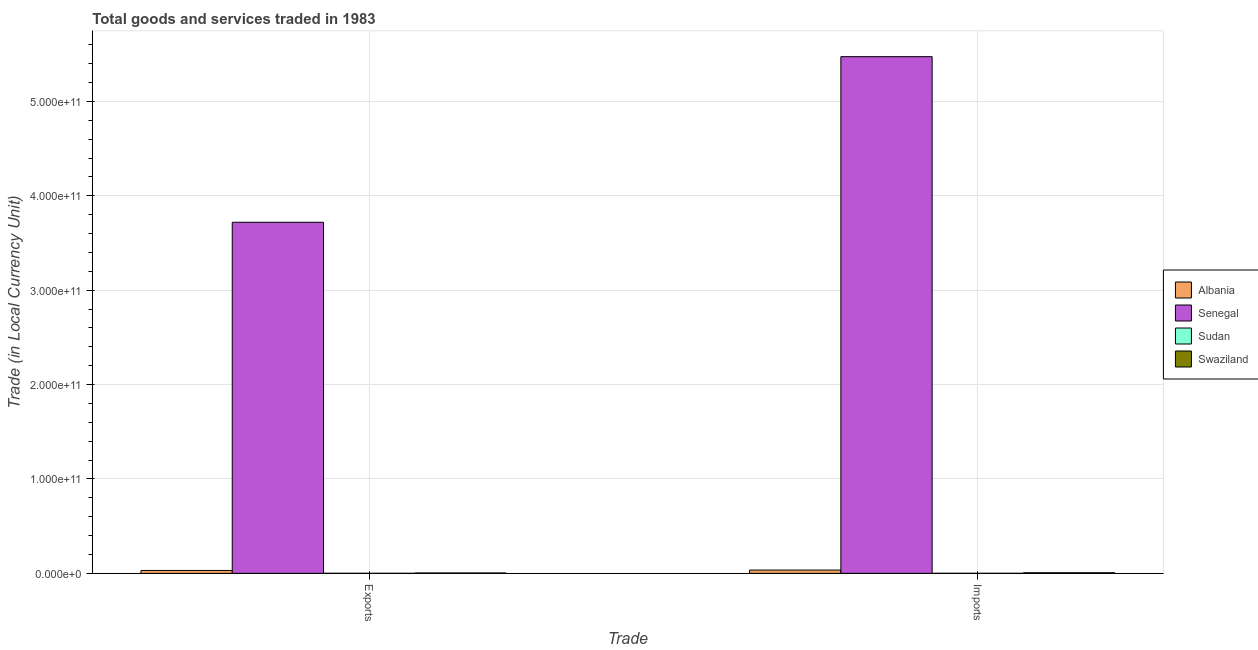How many different coloured bars are there?
Offer a terse response. 4. What is the label of the 1st group of bars from the left?
Ensure brevity in your answer.  Exports. What is the imports of goods and services in Sudan?
Provide a succinct answer. 2.27e+06. Across all countries, what is the maximum export of goods and services?
Keep it short and to the point. 3.72e+11. Across all countries, what is the minimum imports of goods and services?
Your response must be concise. 2.27e+06. In which country was the imports of goods and services maximum?
Your answer should be very brief. Senegal. In which country was the imports of goods and services minimum?
Make the answer very short. Sudan. What is the total imports of goods and services in the graph?
Provide a short and direct response. 5.52e+11. What is the difference between the imports of goods and services in Albania and that in Swaziland?
Offer a very short reply. 2.86e+09. What is the difference between the imports of goods and services in Senegal and the export of goods and services in Swaziland?
Your answer should be very brief. 5.47e+11. What is the average export of goods and services per country?
Your answer should be compact. 9.38e+1. What is the difference between the imports of goods and services and export of goods and services in Swaziland?
Make the answer very short. 2.37e+08. What is the ratio of the export of goods and services in Swaziland to that in Sudan?
Ensure brevity in your answer.  339.01. In how many countries, is the export of goods and services greater than the average export of goods and services taken over all countries?
Your answer should be very brief. 1. What does the 2nd bar from the left in Imports represents?
Keep it short and to the point. Senegal. What does the 4th bar from the right in Exports represents?
Offer a very short reply. Albania. How many bars are there?
Offer a very short reply. 8. Are all the bars in the graph horizontal?
Your answer should be compact. No. What is the difference between two consecutive major ticks on the Y-axis?
Your response must be concise. 1.00e+11. Are the values on the major ticks of Y-axis written in scientific E-notation?
Give a very brief answer. Yes. Does the graph contain any zero values?
Your response must be concise. No. Where does the legend appear in the graph?
Offer a very short reply. Center right. What is the title of the graph?
Make the answer very short. Total goods and services traded in 1983. What is the label or title of the X-axis?
Your answer should be very brief. Trade. What is the label or title of the Y-axis?
Your answer should be compact. Trade (in Local Currency Unit). What is the Trade (in Local Currency Unit) of Albania in Exports?
Offer a very short reply. 3.04e+09. What is the Trade (in Local Currency Unit) of Senegal in Exports?
Your answer should be very brief. 3.72e+11. What is the Trade (in Local Currency Unit) of Sudan in Exports?
Keep it short and to the point. 1.13e+06. What is the Trade (in Local Currency Unit) in Swaziland in Exports?
Make the answer very short. 3.84e+08. What is the Trade (in Local Currency Unit) in Albania in Imports?
Offer a terse response. 3.48e+09. What is the Trade (in Local Currency Unit) in Senegal in Imports?
Make the answer very short. 5.47e+11. What is the Trade (in Local Currency Unit) of Sudan in Imports?
Make the answer very short. 2.27e+06. What is the Trade (in Local Currency Unit) of Swaziland in Imports?
Offer a terse response. 6.21e+08. Across all Trade, what is the maximum Trade (in Local Currency Unit) in Albania?
Provide a short and direct response. 3.48e+09. Across all Trade, what is the maximum Trade (in Local Currency Unit) of Senegal?
Provide a short and direct response. 5.47e+11. Across all Trade, what is the maximum Trade (in Local Currency Unit) in Sudan?
Keep it short and to the point. 2.27e+06. Across all Trade, what is the maximum Trade (in Local Currency Unit) in Swaziland?
Offer a very short reply. 6.21e+08. Across all Trade, what is the minimum Trade (in Local Currency Unit) in Albania?
Provide a succinct answer. 3.04e+09. Across all Trade, what is the minimum Trade (in Local Currency Unit) in Senegal?
Make the answer very short. 3.72e+11. Across all Trade, what is the minimum Trade (in Local Currency Unit) of Sudan?
Provide a succinct answer. 1.13e+06. Across all Trade, what is the minimum Trade (in Local Currency Unit) in Swaziland?
Offer a very short reply. 3.84e+08. What is the total Trade (in Local Currency Unit) of Albania in the graph?
Give a very brief answer. 6.52e+09. What is the total Trade (in Local Currency Unit) of Senegal in the graph?
Provide a succinct answer. 9.19e+11. What is the total Trade (in Local Currency Unit) of Sudan in the graph?
Provide a succinct answer. 3.41e+06. What is the total Trade (in Local Currency Unit) in Swaziland in the graph?
Offer a terse response. 1.01e+09. What is the difference between the Trade (in Local Currency Unit) in Albania in Exports and that in Imports?
Give a very brief answer. -4.37e+08. What is the difference between the Trade (in Local Currency Unit) of Senegal in Exports and that in Imports?
Ensure brevity in your answer.  -1.75e+11. What is the difference between the Trade (in Local Currency Unit) in Sudan in Exports and that in Imports?
Your response must be concise. -1.14e+06. What is the difference between the Trade (in Local Currency Unit) of Swaziland in Exports and that in Imports?
Provide a short and direct response. -2.37e+08. What is the difference between the Trade (in Local Currency Unit) in Albania in Exports and the Trade (in Local Currency Unit) in Senegal in Imports?
Offer a terse response. -5.44e+11. What is the difference between the Trade (in Local Currency Unit) of Albania in Exports and the Trade (in Local Currency Unit) of Sudan in Imports?
Your answer should be compact. 3.04e+09. What is the difference between the Trade (in Local Currency Unit) in Albania in Exports and the Trade (in Local Currency Unit) in Swaziland in Imports?
Your answer should be compact. 2.42e+09. What is the difference between the Trade (in Local Currency Unit) in Senegal in Exports and the Trade (in Local Currency Unit) in Sudan in Imports?
Give a very brief answer. 3.72e+11. What is the difference between the Trade (in Local Currency Unit) in Senegal in Exports and the Trade (in Local Currency Unit) in Swaziland in Imports?
Provide a short and direct response. 3.71e+11. What is the difference between the Trade (in Local Currency Unit) of Sudan in Exports and the Trade (in Local Currency Unit) of Swaziland in Imports?
Keep it short and to the point. -6.20e+08. What is the average Trade (in Local Currency Unit) of Albania per Trade?
Ensure brevity in your answer.  3.26e+09. What is the average Trade (in Local Currency Unit) of Senegal per Trade?
Give a very brief answer. 4.60e+11. What is the average Trade (in Local Currency Unit) in Sudan per Trade?
Keep it short and to the point. 1.70e+06. What is the average Trade (in Local Currency Unit) of Swaziland per Trade?
Ensure brevity in your answer.  5.03e+08. What is the difference between the Trade (in Local Currency Unit) in Albania and Trade (in Local Currency Unit) in Senegal in Exports?
Make the answer very short. -3.69e+11. What is the difference between the Trade (in Local Currency Unit) in Albania and Trade (in Local Currency Unit) in Sudan in Exports?
Your response must be concise. 3.04e+09. What is the difference between the Trade (in Local Currency Unit) in Albania and Trade (in Local Currency Unit) in Swaziland in Exports?
Ensure brevity in your answer.  2.66e+09. What is the difference between the Trade (in Local Currency Unit) of Senegal and Trade (in Local Currency Unit) of Sudan in Exports?
Offer a terse response. 3.72e+11. What is the difference between the Trade (in Local Currency Unit) of Senegal and Trade (in Local Currency Unit) of Swaziland in Exports?
Keep it short and to the point. 3.72e+11. What is the difference between the Trade (in Local Currency Unit) of Sudan and Trade (in Local Currency Unit) of Swaziland in Exports?
Give a very brief answer. -3.83e+08. What is the difference between the Trade (in Local Currency Unit) of Albania and Trade (in Local Currency Unit) of Senegal in Imports?
Give a very brief answer. -5.44e+11. What is the difference between the Trade (in Local Currency Unit) of Albania and Trade (in Local Currency Unit) of Sudan in Imports?
Ensure brevity in your answer.  3.48e+09. What is the difference between the Trade (in Local Currency Unit) in Albania and Trade (in Local Currency Unit) in Swaziland in Imports?
Provide a short and direct response. 2.86e+09. What is the difference between the Trade (in Local Currency Unit) of Senegal and Trade (in Local Currency Unit) of Sudan in Imports?
Your answer should be very brief. 5.47e+11. What is the difference between the Trade (in Local Currency Unit) in Senegal and Trade (in Local Currency Unit) in Swaziland in Imports?
Offer a very short reply. 5.47e+11. What is the difference between the Trade (in Local Currency Unit) of Sudan and Trade (in Local Currency Unit) of Swaziland in Imports?
Ensure brevity in your answer.  -6.19e+08. What is the ratio of the Trade (in Local Currency Unit) in Albania in Exports to that in Imports?
Your answer should be compact. 0.87. What is the ratio of the Trade (in Local Currency Unit) of Senegal in Exports to that in Imports?
Your answer should be compact. 0.68. What is the ratio of the Trade (in Local Currency Unit) in Sudan in Exports to that in Imports?
Make the answer very short. 0.5. What is the ratio of the Trade (in Local Currency Unit) of Swaziland in Exports to that in Imports?
Provide a short and direct response. 0.62. What is the difference between the highest and the second highest Trade (in Local Currency Unit) in Albania?
Keep it short and to the point. 4.37e+08. What is the difference between the highest and the second highest Trade (in Local Currency Unit) of Senegal?
Your answer should be compact. 1.75e+11. What is the difference between the highest and the second highest Trade (in Local Currency Unit) in Sudan?
Make the answer very short. 1.14e+06. What is the difference between the highest and the second highest Trade (in Local Currency Unit) in Swaziland?
Offer a very short reply. 2.37e+08. What is the difference between the highest and the lowest Trade (in Local Currency Unit) of Albania?
Your response must be concise. 4.37e+08. What is the difference between the highest and the lowest Trade (in Local Currency Unit) of Senegal?
Your answer should be compact. 1.75e+11. What is the difference between the highest and the lowest Trade (in Local Currency Unit) in Sudan?
Make the answer very short. 1.14e+06. What is the difference between the highest and the lowest Trade (in Local Currency Unit) of Swaziland?
Offer a very short reply. 2.37e+08. 